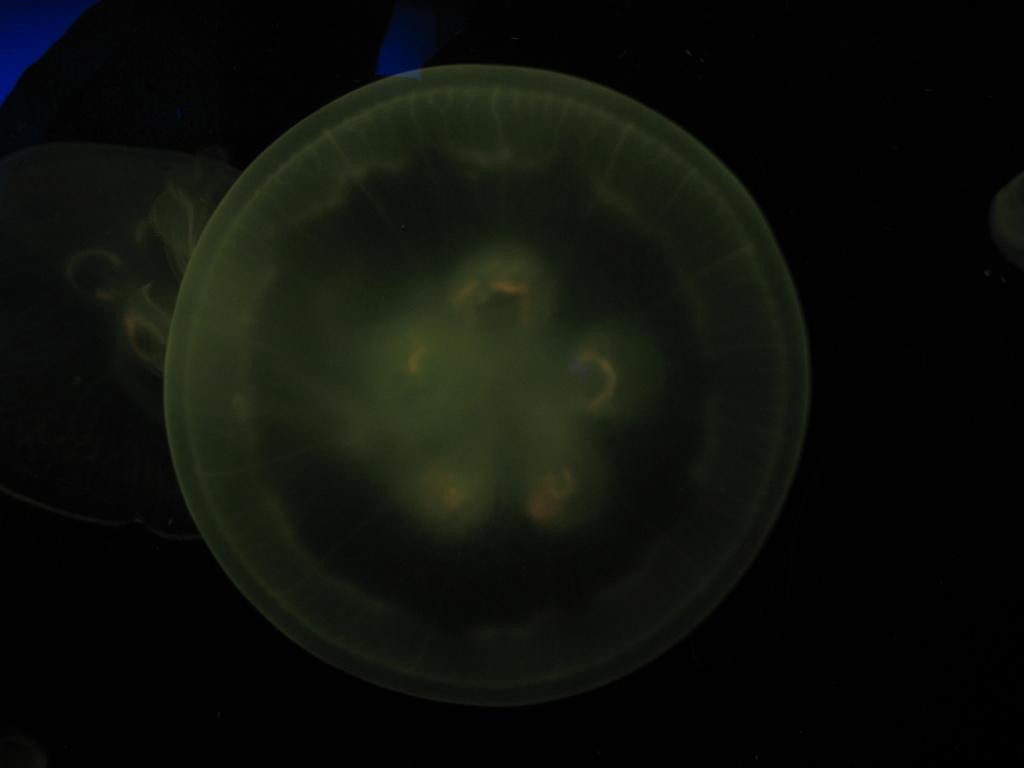Can you describe this image briefly? This is a picture of a jellyfish , and there is dark background. 